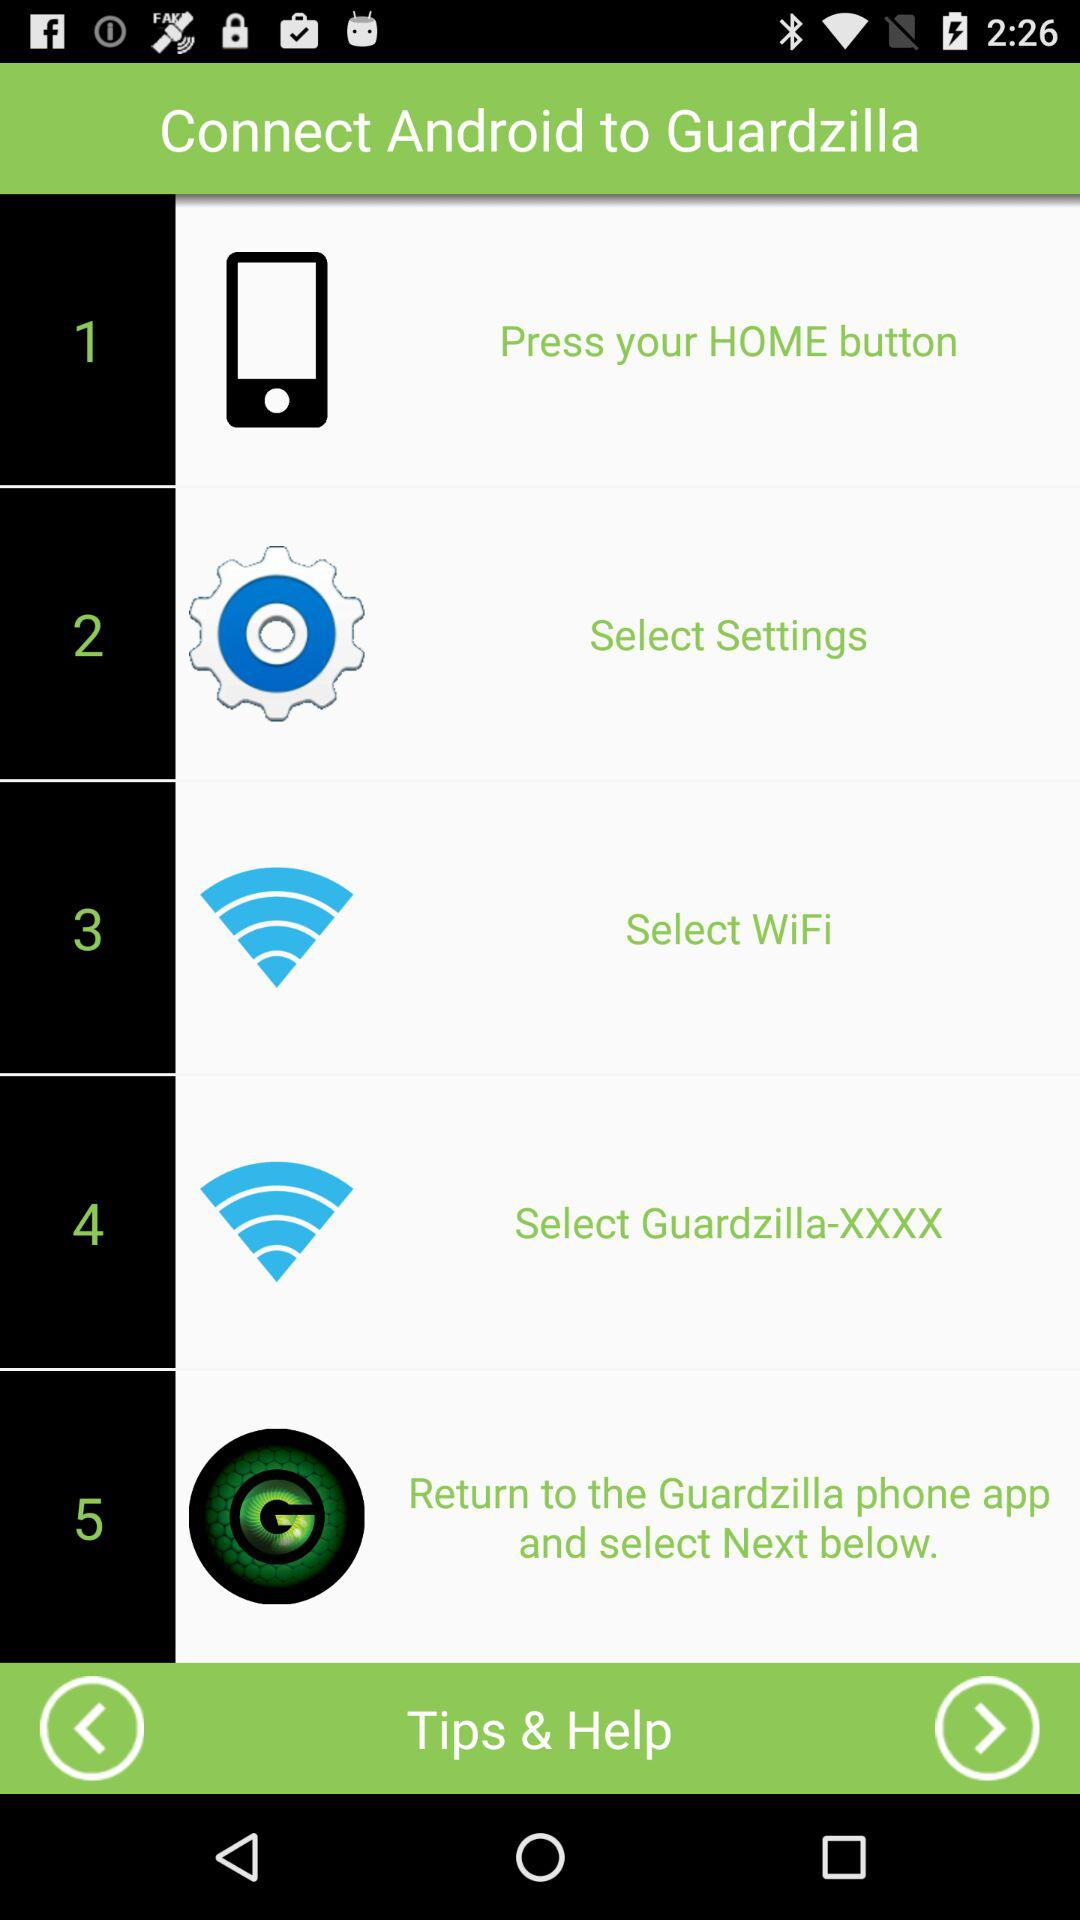What are the steps to connect Android to GuardZilla? The steps are "Press your HOME button", "Select Settings", "Select WiFi", "Select Guardzilla-XXXX" and "Return to the Guardzilla phone app and select Next below.". 